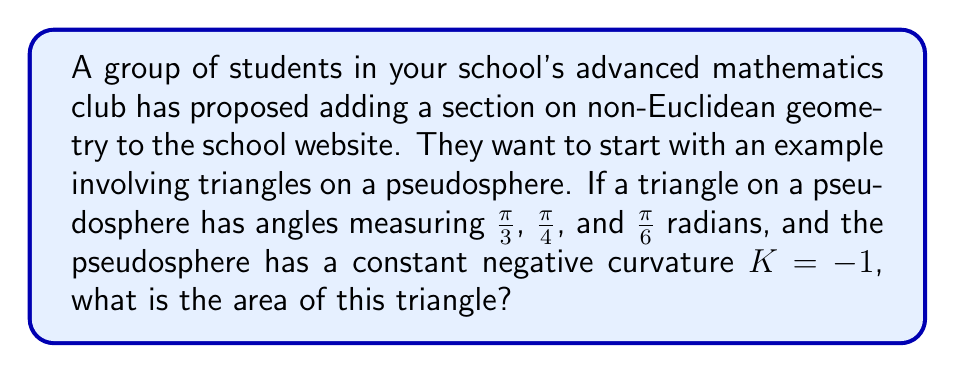Could you help me with this problem? Let's approach this step-by-step:

1) In non-Euclidean geometry, specifically on a pseudosphere (a surface of constant negative curvature), the area of a triangle is given by the Gauss-Bonnet formula:

   $$A = -K(\alpha + \beta + \gamma - \pi)$$

   Where $A$ is the area, $K$ is the Gaussian curvature, and $\alpha$, $\beta$, and $\gamma$ are the angles of the triangle.

2) We are given that $K = -1$, so our formula becomes:

   $$A = \alpha + \beta + \gamma - \pi$$

3) Let's sum up the given angles:

   $$\alpha = \frac{\pi}{3}, \beta = \frac{\pi}{4}, \gamma = \frac{\pi}{6}$$

   $$\alpha + \beta + \gamma = \frac{\pi}{3} + \frac{\pi}{4} + \frac{\pi}{6}$$

4) To add these fractions, we need a common denominator. The least common multiple of 3, 4, and 6 is 12:

   $$\frac{\pi}{3} + \frac{\pi}{4} + \frac{\pi}{6} = \frac{4\pi}{12} + \frac{3\pi}{12} + \frac{2\pi}{12} = \frac{9\pi}{12} = \frac{3\pi}{4}$$

5) Now we can substitute this into our area formula:

   $$A = \frac{3\pi}{4} - \pi = -\frac{\pi}{4}$$

6) The negative sign here indicates that this area is "excess" area compared to a Euclidean triangle. In the context of a pseudosphere, we typically consider the absolute value of this result.

Therefore, the area of the triangle is $\frac{\pi}{4}$ square units.
Answer: $\frac{\pi}{4}$ square units 